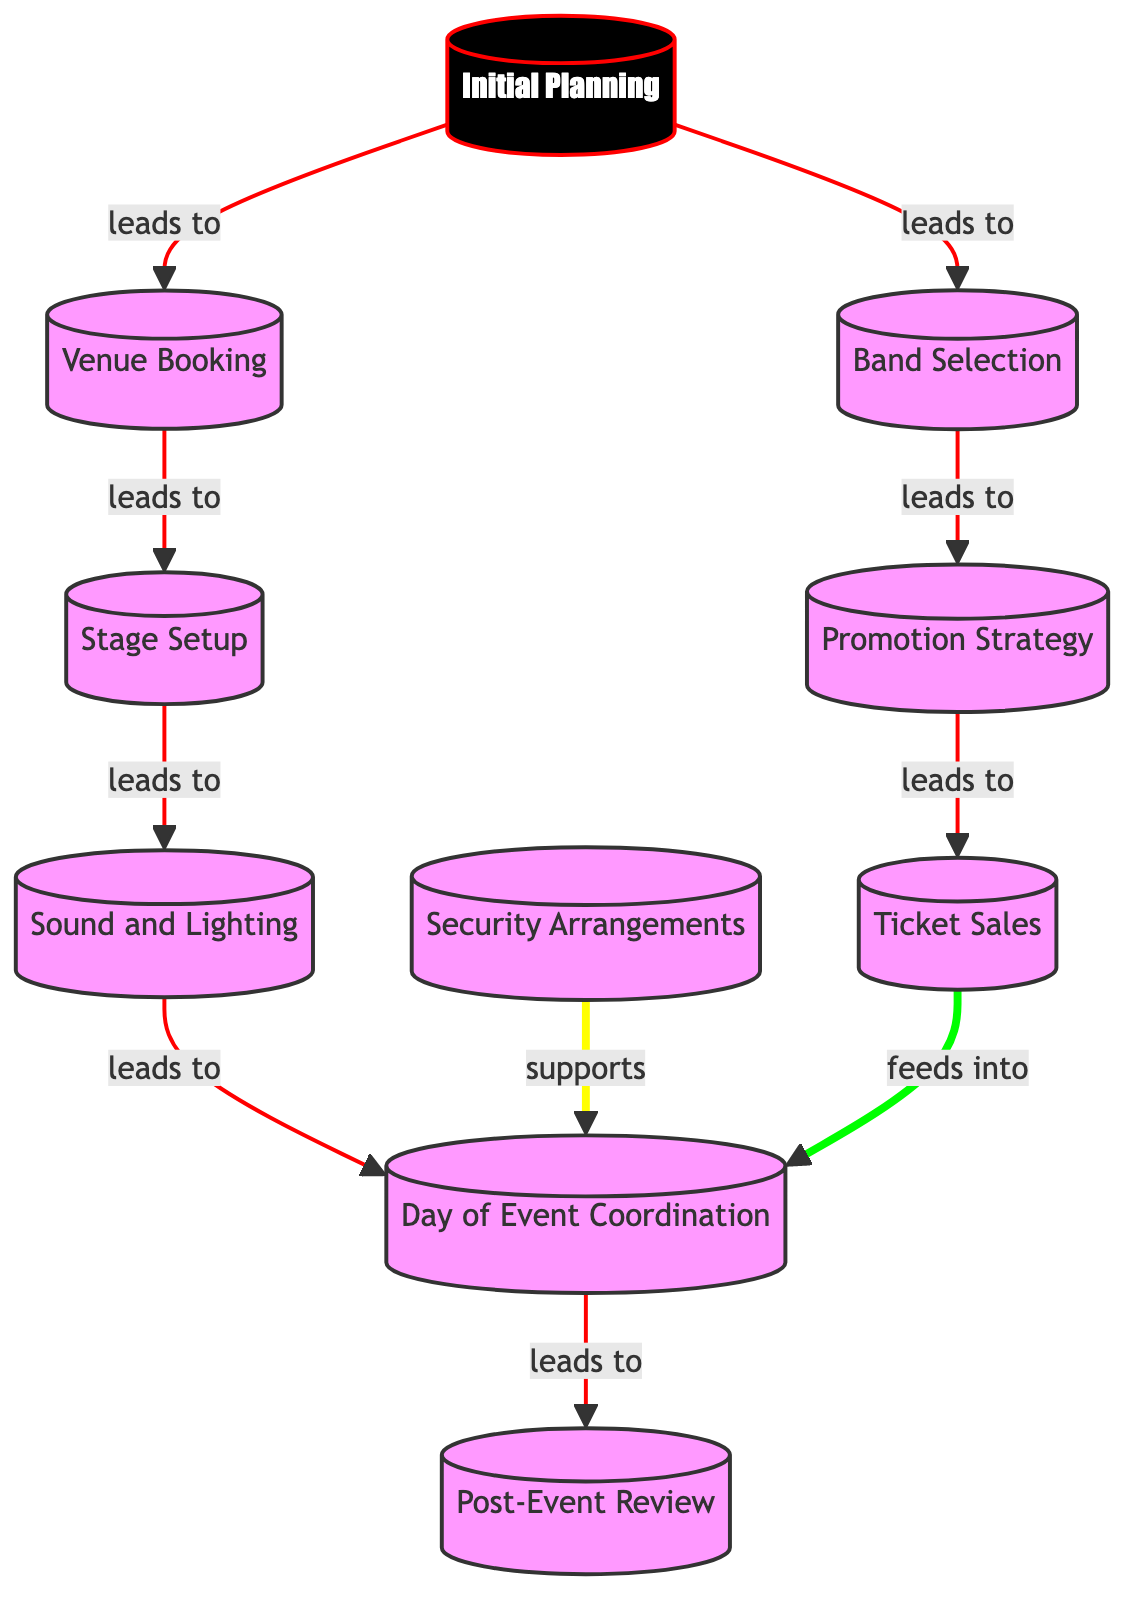What's the total number of nodes in the graph? The graph contains a set of nodes that represent different tasks in event planning. Counting the nodes, we see: Initial Planning, Venue Booking, Band Selection, Promotion Strategy, Ticket Sales, Stage Setup, Sound and Lighting, Security Arrangements, Day of Event Coordination, and Post-Event Review. This totals to 10 nodes.
Answer: 10 How many edges lead from the "Initial Planning" node? The "Initial Planning" node connects to two nodes: Venue Booking and Band Selection. We can see this by examining the edges drawn from node 1 in the diagram. Therefore, it has 2 outgoing edges.
Answer: 2 What is the task following "Promotion Strategy"? From the diagram, the edge from Band Selection to Promotion Strategy shows that Promotion Strategy directly follows Band Selection as it leads to the Ticket Sales node.
Answer: Ticket Sales What type of relationship exists between "Security Arrangements" and "Day of Event Coordination"? The edge from Security Arrangements to Day of Event Coordination indicates that Security Arrangements support the Day of Event Coordination, indicating a supportive relationship rather than a direct lead.
Answer: supports Which node has the highest number of incoming edges? By reviewing the edges, we see that the Day of Event Coordination node has three incoming edges: from Ticket Sales, Sound and Lighting, and Security Arrangements. Thus, it has the highest number of incoming edges.
Answer: Day of Event Coordination What is the role of "Sound and Lighting" in the event planning process? The diagram shows that Sound and Lighting is directly connected to Day of Event Coordination, meaning it is part of the essential tasks that lead up to the event day. It plays a crucial role in ensuring the technical aspects of the gig are handled.
Answer: leads to Which task does not lead to any other node in the graph? Looking through the edges, we can identify that Post-Event Review is the final task in the diagram. It does not lead to any other node, indicating it is the last step in the process.
Answer: Post-Event Review How does "Ticket Sales" contribute to the day of the event? Ticket Sales feeds into Day of Event Coordination, indicating that it contributes by ensuring that ticket sales are handled before the event coordination begins on the event day. This vital input helps to organize the attendance effectively.
Answer: feeds into 